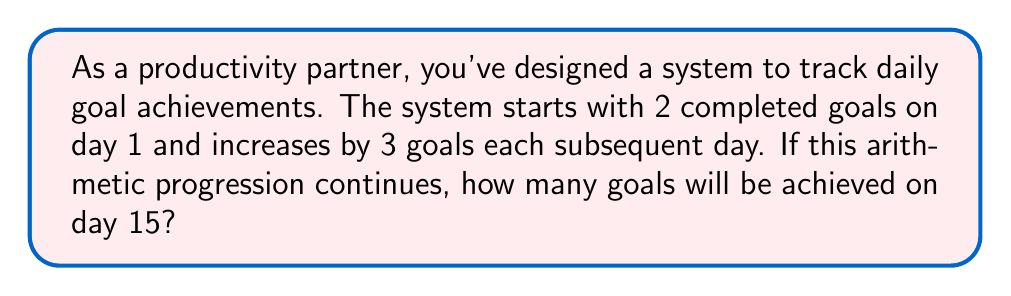Solve this math problem. Let's approach this step-by-step using the arithmetic progression formula:

1) In an arithmetic progression, the nth term is given by:
   $a_n = a_1 + (n-1)d$
   where $a_1$ is the first term, $n$ is the position of the term, and $d$ is the common difference.

2) In this case:
   $a_1 = 2$ (first day's achievement)
   $d = 3$ (daily increase)
   $n = 15$ (we're looking for the 15th day)

3) Substituting these values into the formula:
   $a_{15} = 2 + (15-1)3$

4) Simplify:
   $a_{15} = 2 + (14)3$
   $a_{15} = 2 + 42$
   $a_{15} = 44$

Therefore, on day 15, 44 goals will be achieved.
Answer: 44 goals 